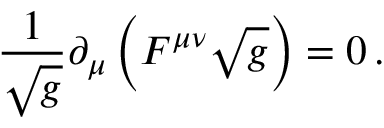<formula> <loc_0><loc_0><loc_500><loc_500>{ \frac { 1 } { \sqrt { g } } } \partial _ { \mu } \left ( F ^ { \mu \nu } \sqrt { g } \right ) = 0 \, .</formula> 